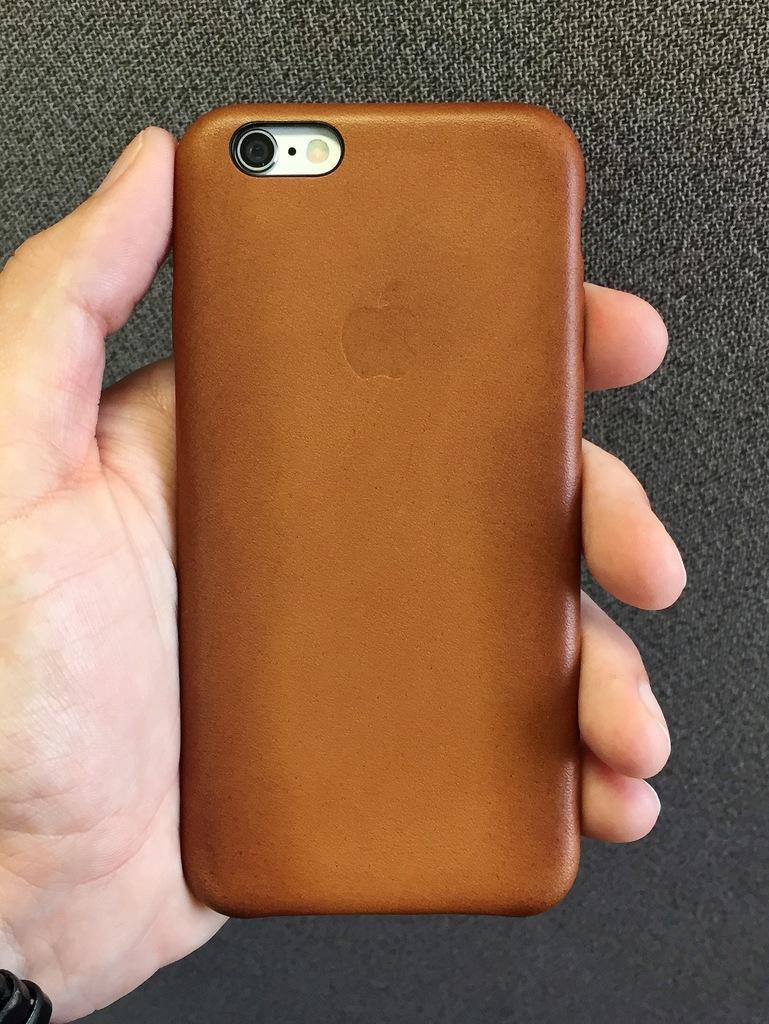Can you describe this image briefly? In this image, we can see a hand holding a phone. 